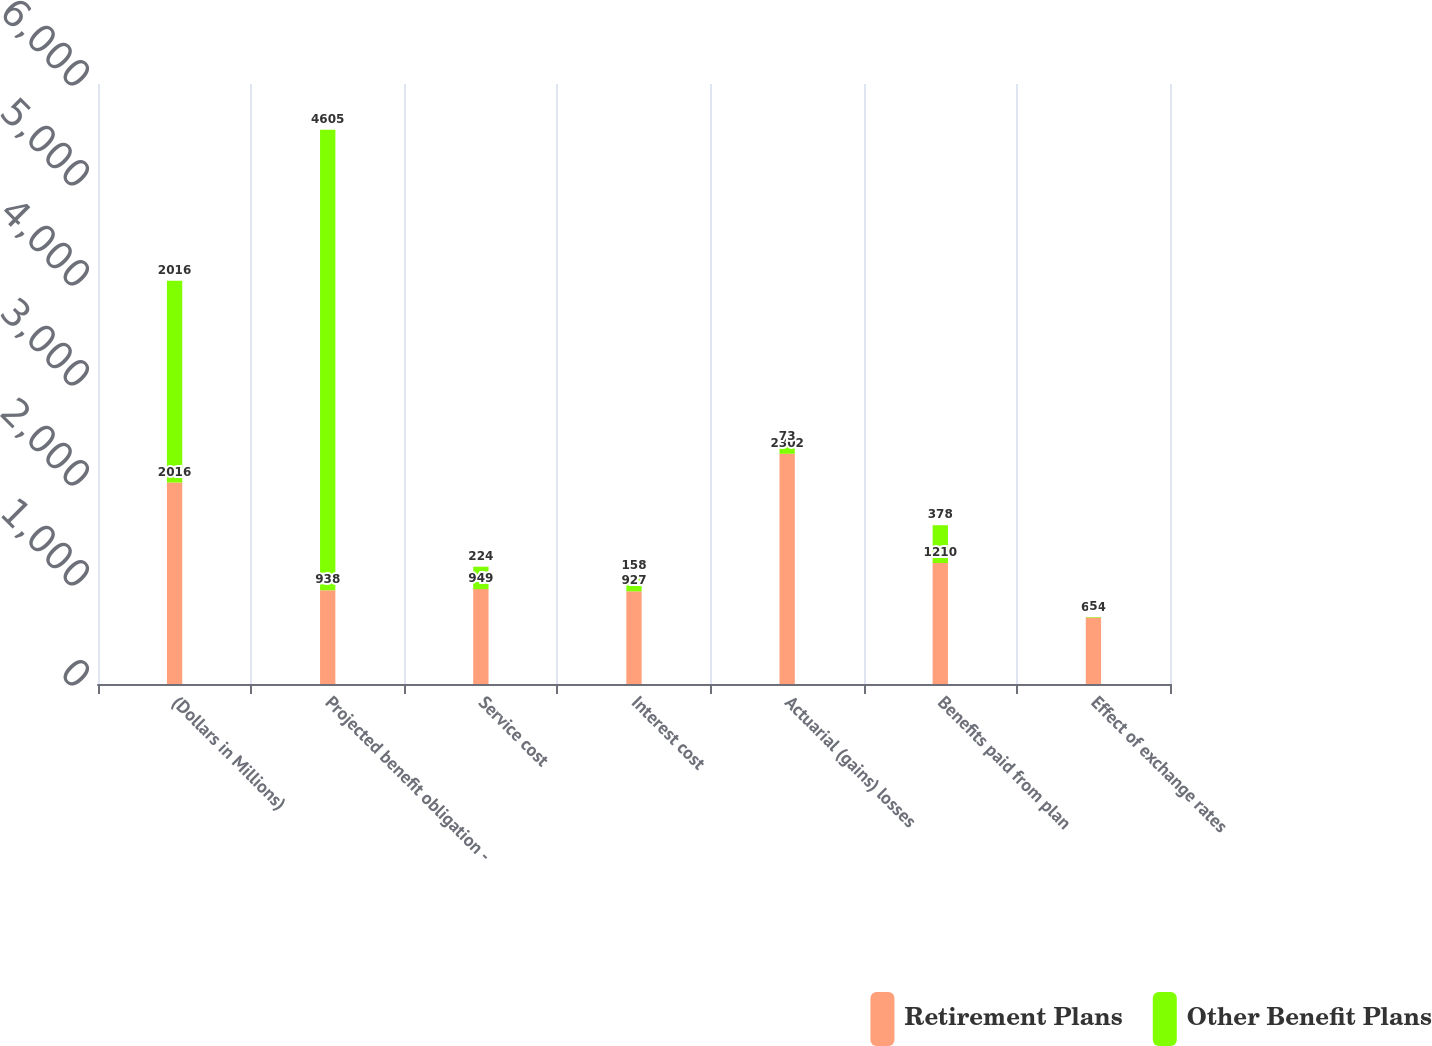<chart> <loc_0><loc_0><loc_500><loc_500><stacked_bar_chart><ecel><fcel>(Dollars in Millions)<fcel>Projected benefit obligation -<fcel>Service cost<fcel>Interest cost<fcel>Actuarial (gains) losses<fcel>Benefits paid from plan<fcel>Effect of exchange rates<nl><fcel>Retirement Plans<fcel>2016<fcel>938<fcel>949<fcel>927<fcel>2302<fcel>1210<fcel>664<nl><fcel>Other Benefit Plans<fcel>2016<fcel>4605<fcel>224<fcel>158<fcel>73<fcel>378<fcel>5<nl></chart> 